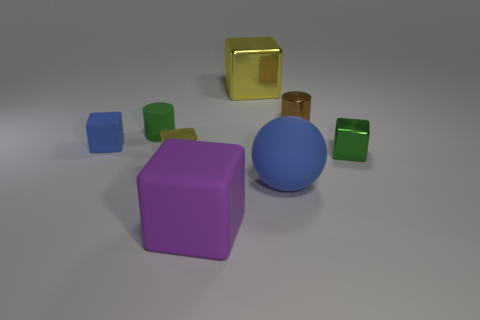Does the tiny brown metallic object have the same shape as the green matte thing?
Give a very brief answer. Yes. How many things are large purple shiny objects or rubber objects that are on the right side of the small matte cylinder?
Provide a succinct answer. 2. What number of matte cubes are there?
Provide a succinct answer. 2. Are there any balls that have the same size as the purple matte block?
Provide a short and direct response. Yes. Is the number of big blue objects that are behind the rubber cylinder less than the number of tiny brown metal cylinders?
Give a very brief answer. Yes. Is the brown cylinder the same size as the blue block?
Your answer should be very brief. Yes. The cylinder that is made of the same material as the ball is what size?
Ensure brevity in your answer.  Small. How many balls are the same color as the tiny rubber cylinder?
Your answer should be very brief. 0. Are there fewer tiny green cubes that are behind the big purple cube than green matte objects that are right of the blue matte ball?
Your answer should be compact. No. Does the blue matte object that is to the left of the tiny yellow metal cube have the same shape as the tiny brown thing?
Ensure brevity in your answer.  No. 